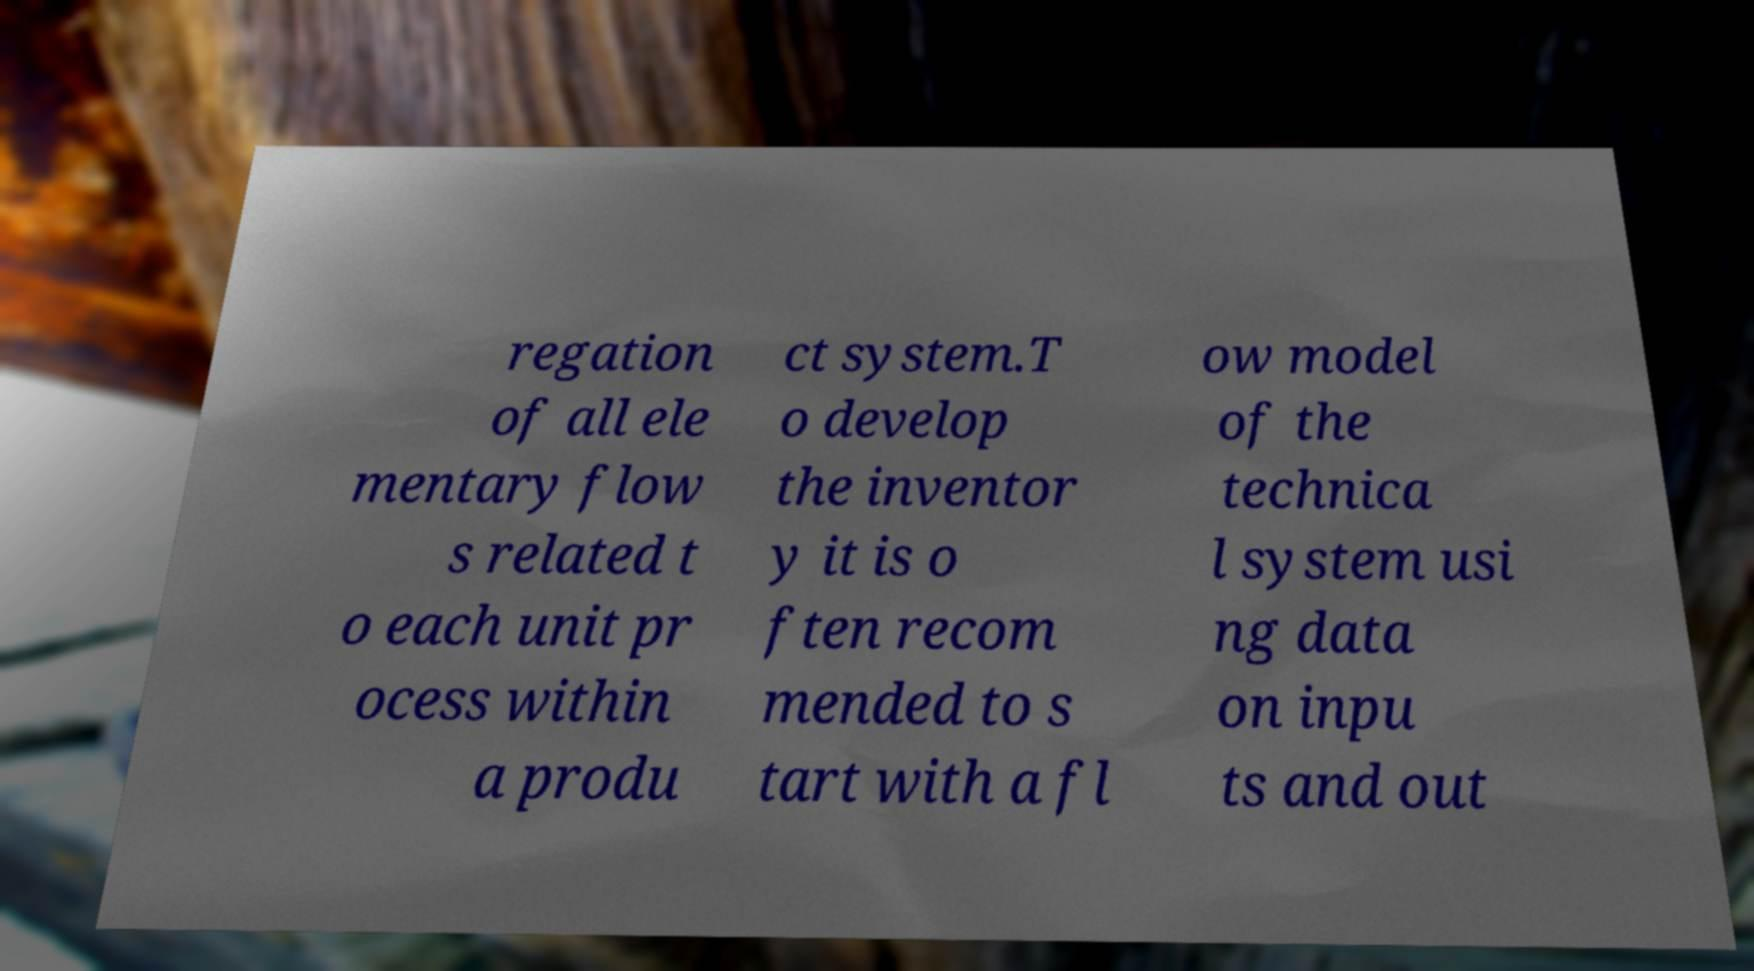Could you extract and type out the text from this image? regation of all ele mentary flow s related t o each unit pr ocess within a produ ct system.T o develop the inventor y it is o ften recom mended to s tart with a fl ow model of the technica l system usi ng data on inpu ts and out 